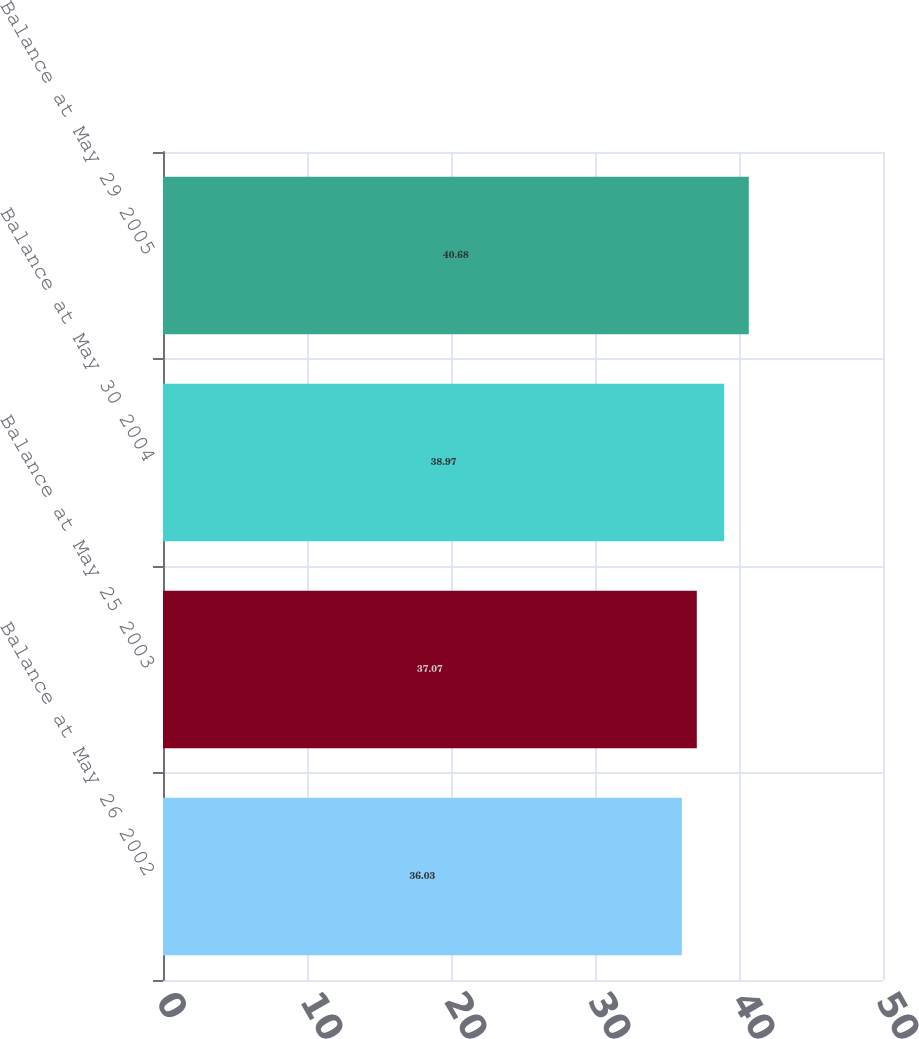Convert chart. <chart><loc_0><loc_0><loc_500><loc_500><bar_chart><fcel>Balance at May 26 2002<fcel>Balance at May 25 2003<fcel>Balance at May 30 2004<fcel>Balance at May 29 2005<nl><fcel>36.03<fcel>37.07<fcel>38.97<fcel>40.68<nl></chart> 